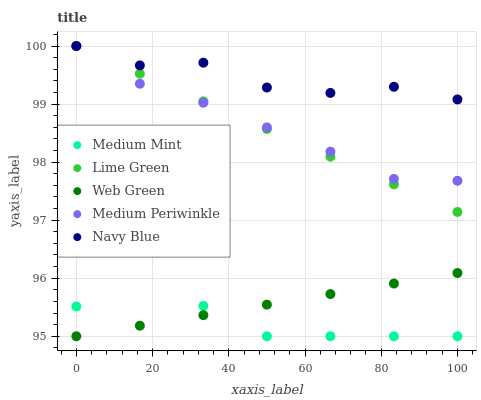Does Medium Mint have the minimum area under the curve?
Answer yes or no. Yes. Does Navy Blue have the maximum area under the curve?
Answer yes or no. Yes. Does Medium Periwinkle have the minimum area under the curve?
Answer yes or no. No. Does Medium Periwinkle have the maximum area under the curve?
Answer yes or no. No. Is Web Green the smoothest?
Answer yes or no. Yes. Is Medium Mint the roughest?
Answer yes or no. Yes. Is Medium Periwinkle the smoothest?
Answer yes or no. No. Is Medium Periwinkle the roughest?
Answer yes or no. No. Does Medium Mint have the lowest value?
Answer yes or no. Yes. Does Medium Periwinkle have the lowest value?
Answer yes or no. No. Does Navy Blue have the highest value?
Answer yes or no. Yes. Does Web Green have the highest value?
Answer yes or no. No. Is Medium Mint less than Lime Green?
Answer yes or no. Yes. Is Navy Blue greater than Medium Mint?
Answer yes or no. Yes. Does Lime Green intersect Navy Blue?
Answer yes or no. Yes. Is Lime Green less than Navy Blue?
Answer yes or no. No. Is Lime Green greater than Navy Blue?
Answer yes or no. No. Does Medium Mint intersect Lime Green?
Answer yes or no. No. 